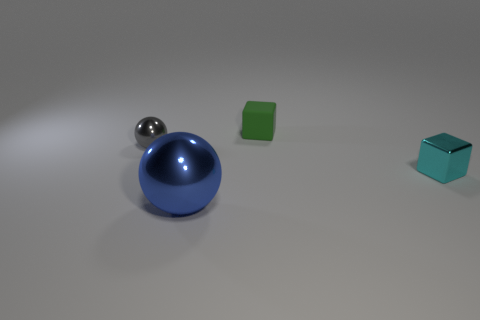Add 1 metal things. How many objects exist? 5 Subtract all gray matte things. Subtract all small gray balls. How many objects are left? 3 Add 2 blue metallic things. How many blue metallic things are left? 3 Add 4 tiny cyan blocks. How many tiny cyan blocks exist? 5 Subtract 1 blue spheres. How many objects are left? 3 